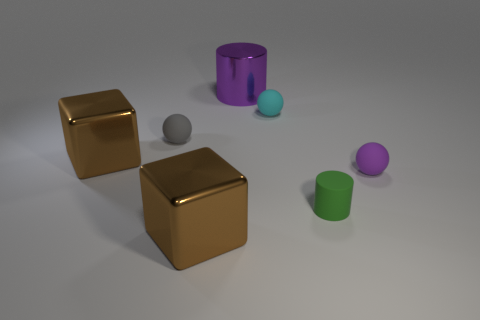How many other things are the same shape as the tiny cyan thing?
Give a very brief answer. 2. There is a metallic object that is to the right of the gray matte thing and left of the large purple metallic cylinder; what is its shape?
Your answer should be very brief. Cube. How big is the cylinder behind the cyan ball?
Keep it short and to the point. Large. Do the matte cylinder and the purple rubber object have the same size?
Offer a very short reply. Yes. Is the number of cyan spheres in front of the gray matte thing less than the number of big objects behind the purple rubber sphere?
Offer a very short reply. Yes. What size is the object that is both in front of the purple matte thing and left of the rubber cylinder?
Your answer should be compact. Large. There is a brown thing that is in front of the tiny sphere in front of the gray rubber ball; is there a big thing in front of it?
Provide a succinct answer. No. Are any tiny gray rubber blocks visible?
Your answer should be very brief. No. Are there more large metallic cylinders left of the purple cylinder than matte cylinders left of the green cylinder?
Offer a very short reply. No. There is a green cylinder that is the same material as the cyan sphere; what is its size?
Provide a succinct answer. Small. 